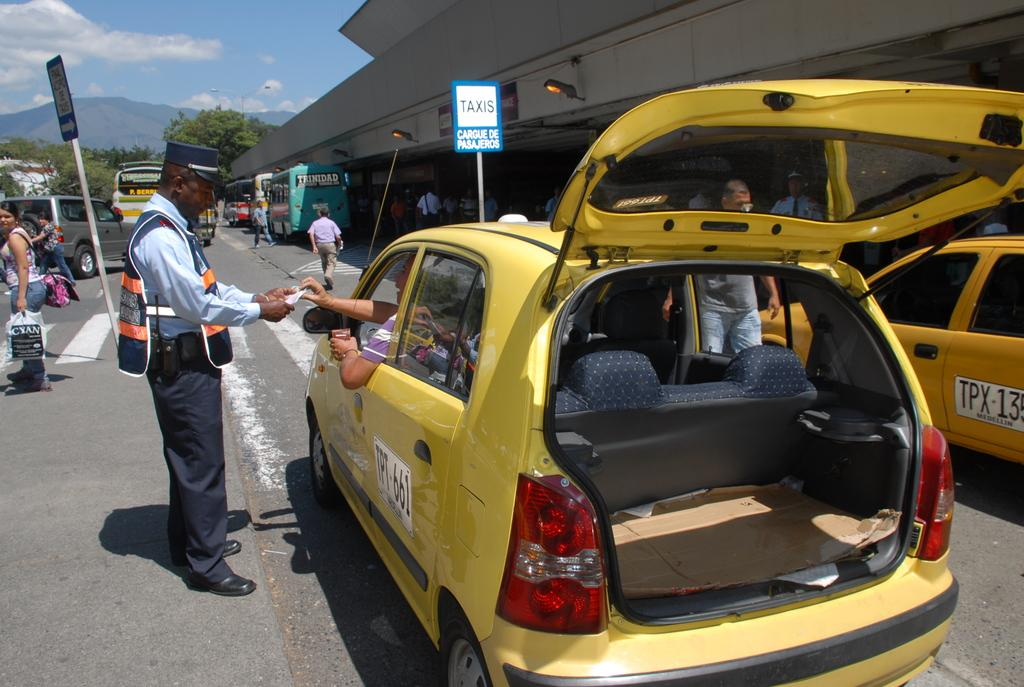Provide a one-sentence caption for the provided image. Two yellow taxis infront of a sign with the word TAXIS on it. 